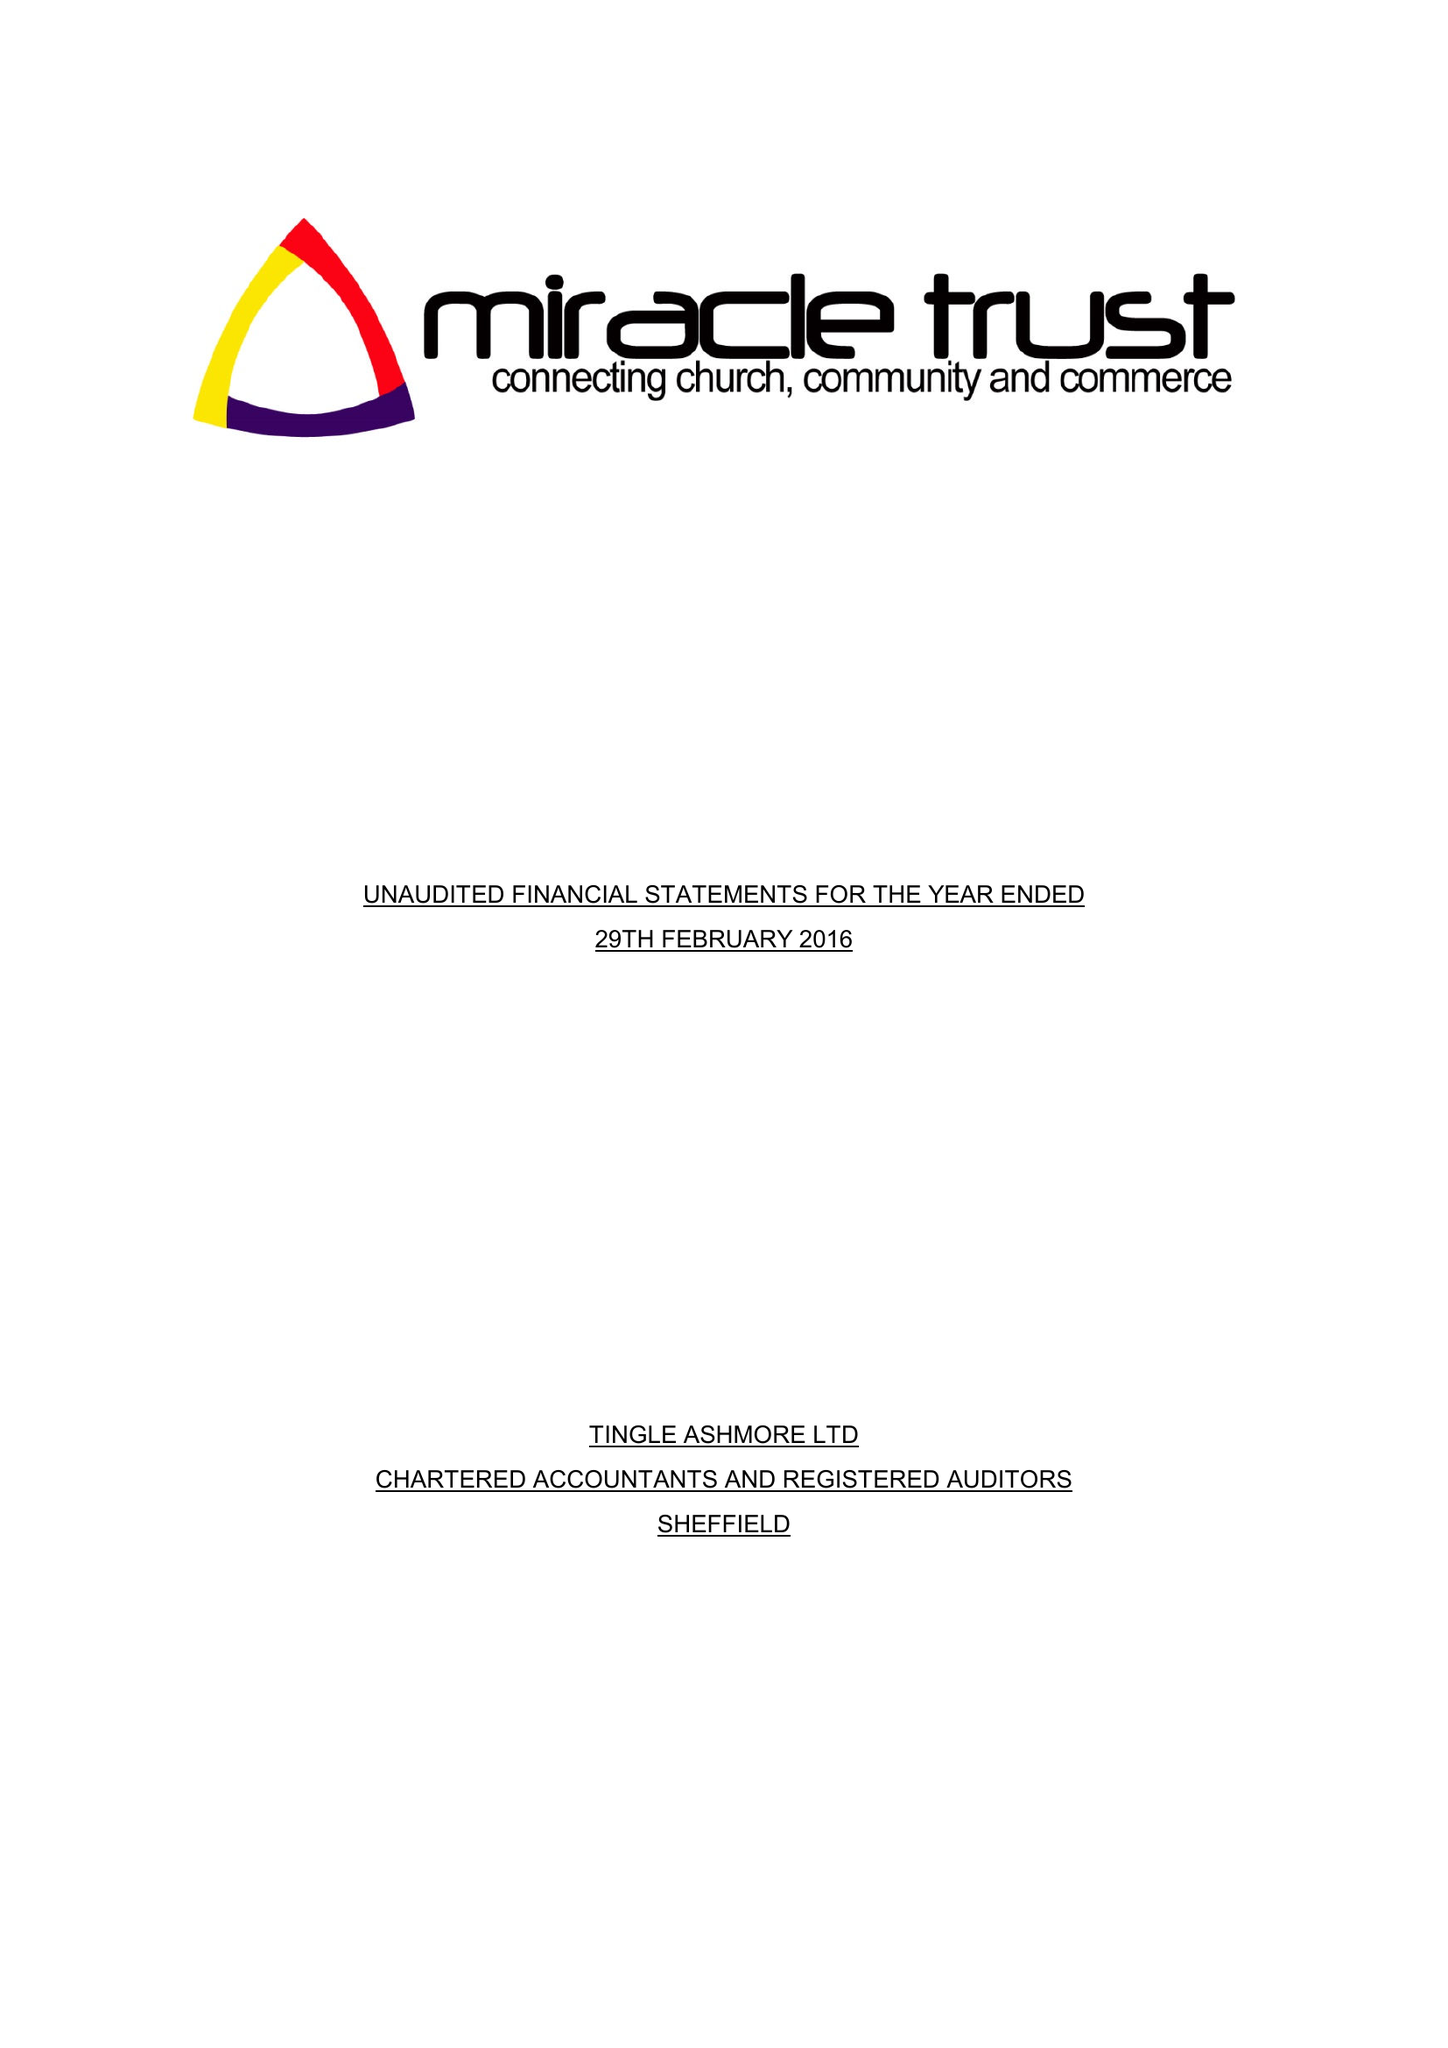What is the value for the charity_name?
Answer the question using a single word or phrase. The Miracle Trust 